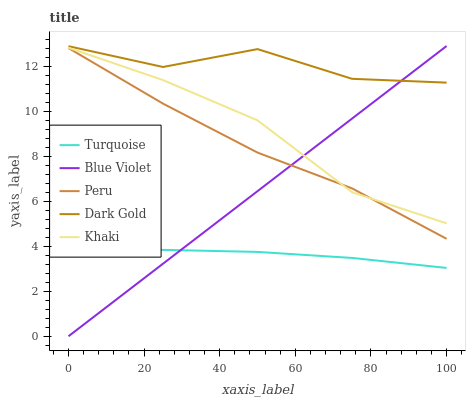Does Turquoise have the minimum area under the curve?
Answer yes or no. Yes. Does Dark Gold have the maximum area under the curve?
Answer yes or no. Yes. Does Khaki have the minimum area under the curve?
Answer yes or no. No. Does Khaki have the maximum area under the curve?
Answer yes or no. No. Is Blue Violet the smoothest?
Answer yes or no. Yes. Is Dark Gold the roughest?
Answer yes or no. Yes. Is Khaki the smoothest?
Answer yes or no. No. Is Khaki the roughest?
Answer yes or no. No. Does Khaki have the lowest value?
Answer yes or no. No. Does Blue Violet have the highest value?
Answer yes or no. Yes. Does Khaki have the highest value?
Answer yes or no. No. Is Khaki less than Dark Gold?
Answer yes or no. Yes. Is Dark Gold greater than Peru?
Answer yes or no. Yes. Does Dark Gold intersect Blue Violet?
Answer yes or no. Yes. Is Dark Gold less than Blue Violet?
Answer yes or no. No. Is Dark Gold greater than Blue Violet?
Answer yes or no. No. Does Khaki intersect Dark Gold?
Answer yes or no. No. 